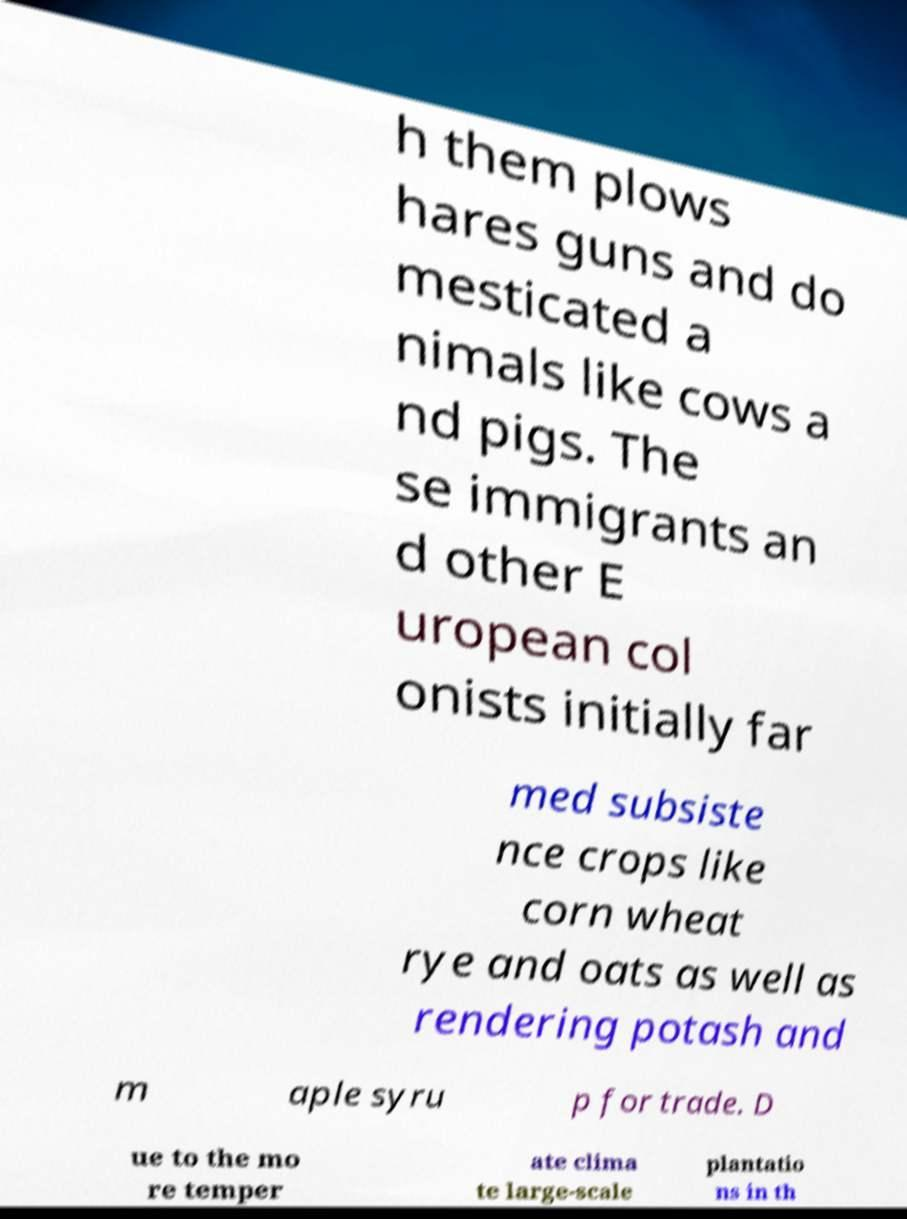There's text embedded in this image that I need extracted. Can you transcribe it verbatim? h them plows hares guns and do mesticated a nimals like cows a nd pigs. The se immigrants an d other E uropean col onists initially far med subsiste nce crops like corn wheat rye and oats as well as rendering potash and m aple syru p for trade. D ue to the mo re temper ate clima te large-scale plantatio ns in th 